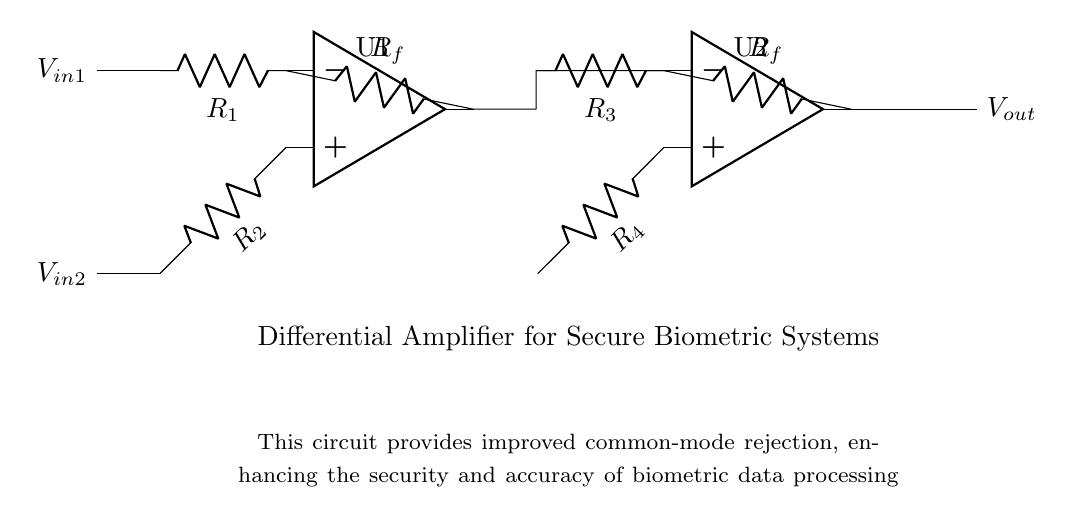What type of amplifier is this? This circuit is a differential amplifier, as identified by the two operational amplifiers used to amplify the difference between two input signals.
Answer: Differential amplifier What is the purpose of the resistors labeled R1 and R2? R1 and R2 are input resistors that determine the gain of the input signals V_in1 and V_in2, allowing the circuit to properly amplify the difference between them.
Answer: Gain determination How many operational amplifiers are present in the circuit? The circuit contains two operational amplifiers, U1 and U2, as indicated by their respective symbols in the diagram.
Answer: Two What does the term "common-mode rejection" refer to in this circuit? Common-mode rejection refers to the circuit's ability to reject input signals that are common to both inputs, enhancing the accuracy and security of the output by minimizing noise interference.
Answer: Noise cancellation What is the output voltage represented by in this circuit? The output voltage, labeled as V_out, is the amplified difference between the input signals processed through the two operational amplifiers.
Answer: V_out What role do the feedback resistors play in this configuration? The feedback resistors, labeled as R_f, are crucial in controlling the gain and stability of the amplifiers, ensuring that the circuit operates correctly and efficiently.
Answer: Gain and stability control 